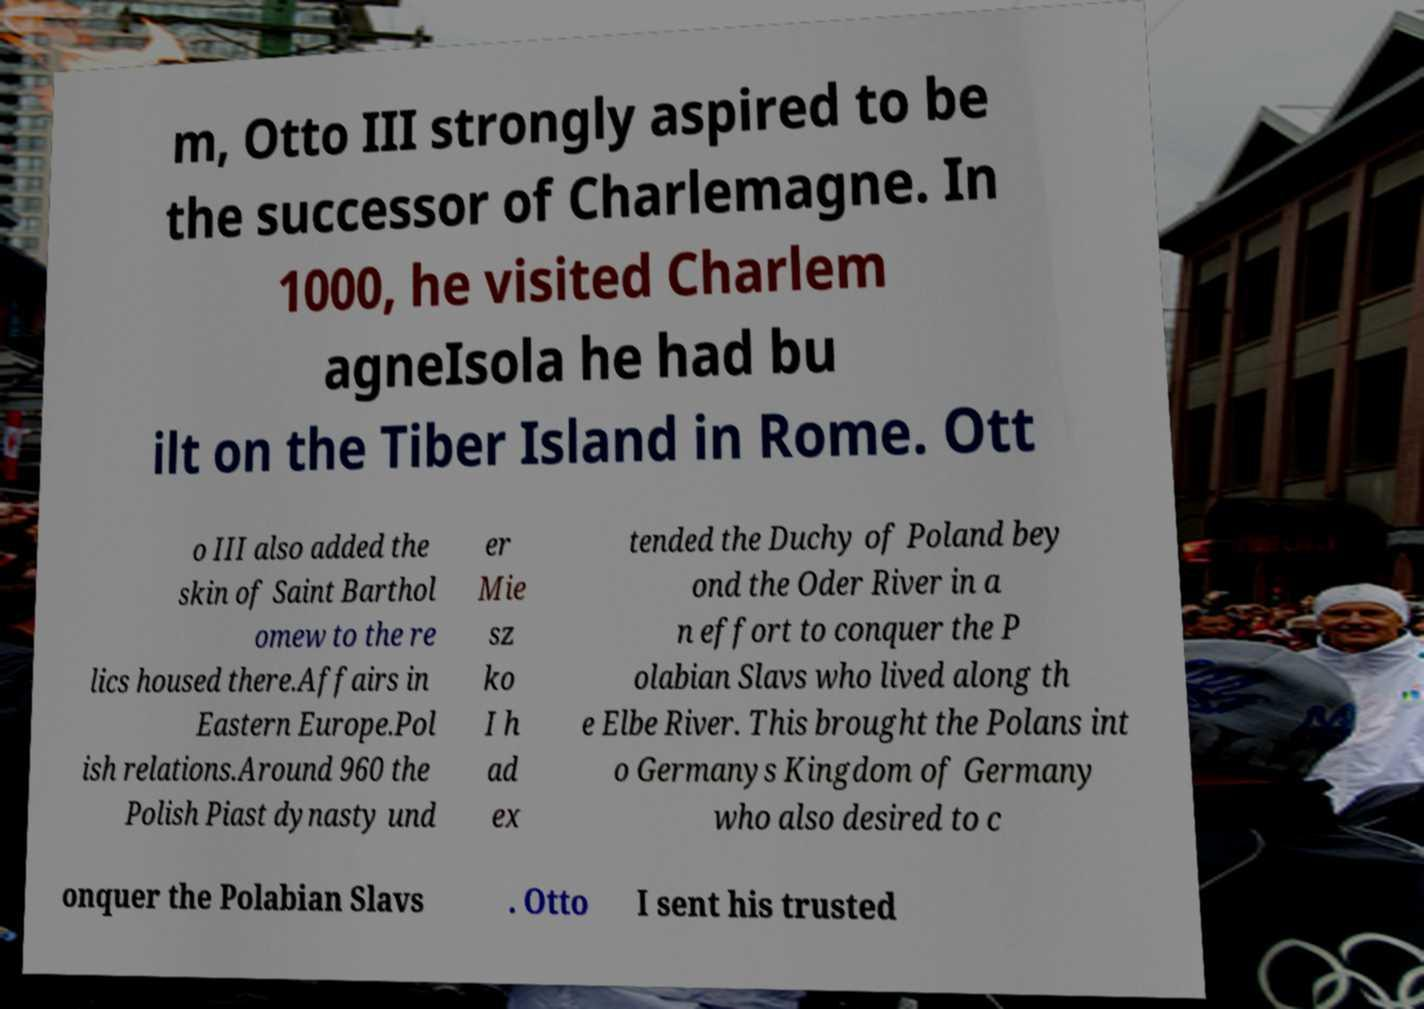What messages or text are displayed in this image? I need them in a readable, typed format. m, Otto III strongly aspired to be the successor of Charlemagne. In 1000, he visited Charlem agneIsola he had bu ilt on the Tiber Island in Rome. Ott o III also added the skin of Saint Barthol omew to the re lics housed there.Affairs in Eastern Europe.Pol ish relations.Around 960 the Polish Piast dynasty und er Mie sz ko I h ad ex tended the Duchy of Poland bey ond the Oder River in a n effort to conquer the P olabian Slavs who lived along th e Elbe River. This brought the Polans int o Germanys Kingdom of Germany who also desired to c onquer the Polabian Slavs . Otto I sent his trusted 